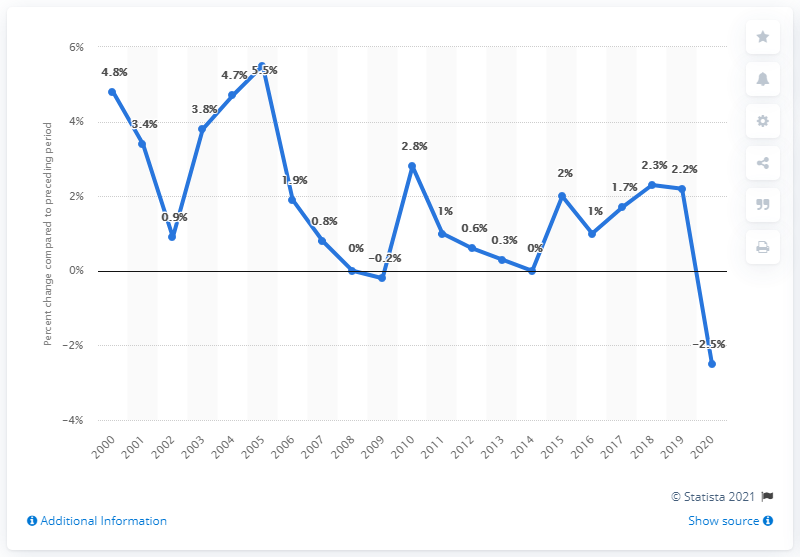Point out several critical features in this image. In 2005, Virginia's Gross Domestic Product (GDP) experienced the most growth out of all the years in its history. 